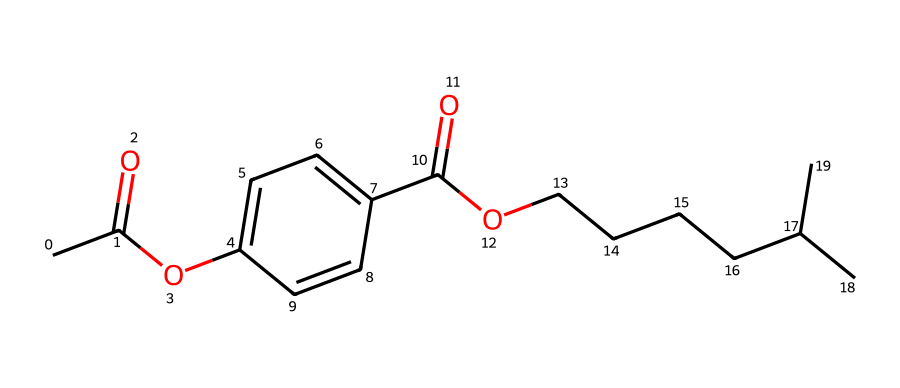what is the main functional group present in this compound? The SMILES representation contains a carbonyl group (C=O) indicated by the presence of "C(=O)" in the structure, which is characteristic of esters and acids.
Answer: carbonyl how many rings are present in this compound? In the SMILES notation, "C1=CC=C(C=C1)" indicates that there is a six-membered aromatic ring due to the 'C1' designation, signifying the start and end of a ring structure. Therefore, there is one ring.
Answer: one what type of compound is this? The presence of a conjugated ring structure and the functional groups suggests this compound belongs to the category of aromatic compounds, as seen with the alternating double bonds in the ring.
Answer: aromatic how many carbon atoms are there in the structure? By analyzing the SMILES representation, we can count each 'C' symbol and account for all carbon atoms included in the formula. In total, there are 20 carbon atoms.
Answer: twenty does this compound exhibit resonance? The presence of alternating double bonds in the aromatic ring ("C1=CC=C") suggests that the pi electrons can be delocalized, which is a hallmark of resonance in aromatic compounds.
Answer: yes what is the longest aliphatic chain present in this compound? In the SMILES representation, "CCCCC(C)C" indicates a linear chain of five carbon atoms with a branching point, hence the longest chain consists of five carbon atoms without interruption.
Answer: five 